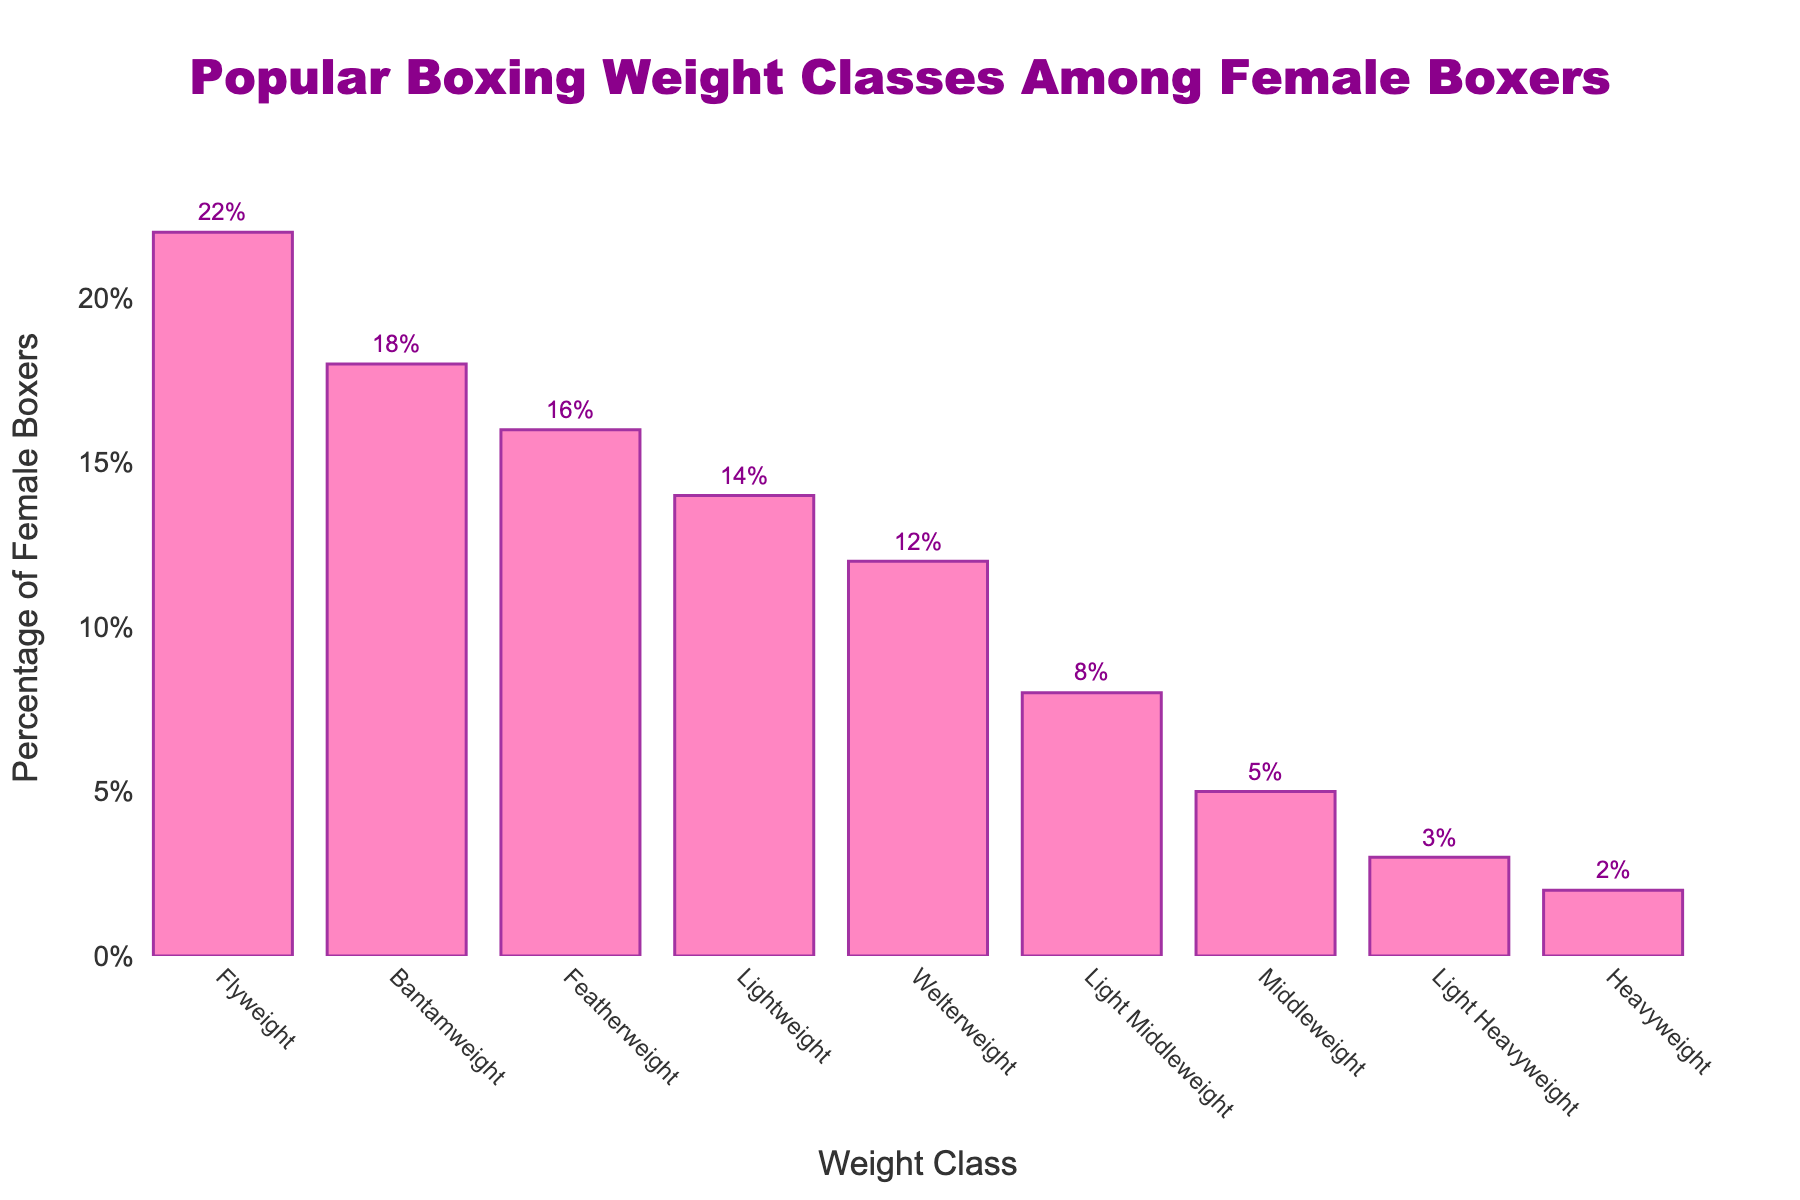What's the most popular weight class among female boxers? Looking at the chart, the weight class with the highest percentage bar is Flyweight with 22%.
Answer: Flyweight Which weight class has a lower percentage of female boxers: Featherweight or Light Heavyweight? Comparing the bars for Featherweight and Light Heavyweight, Featherweight has 16% while Light Heavyweight has 3%. Therefore, Light Heavyweight has a lower percentage.
Answer: Light Heavyweight What is the difference in percentage between Flyweight and Heavyweight boxers? The bar for Flyweight shows 22% and for Heavyweight it shows 2%. The difference is 22% - 2% = 20%.
Answer: 20% How many weight classes have a percentage less than 10%? Observing the chart, Light Middleweight (8%), Middleweight (5%), Light Heavyweight (3%), and Heavyweight (2%) all have percentages less than 10%. This totals to 4 weight classes.
Answer: 4 Is the percentage of boxers in Lightweight greater than in Welterweight? The bar for Lightweight shows 14%, while for Welterweight it shows 12%. Therefore, Lightweight has a greater percentage.
Answer: Yes What is the median percentage of female boxers across all weight classes? List the percentages (2%, 3%, 5%, 8%, 12%, 14%, 16%, 18%, 22%) and find the middle value. The median is 12%.
Answer: 12% Are there more female boxers in the Light Middleweight class or the Middleweight class? Light Middleweight has 8% while Middleweight has 5%. Therefore, Light Middleweight has more.
Answer: Light Middleweight Which weight class has exactly half the percentage of the Flyweight class? The Flyweight class has 22%. Half of that is 11%. Looking at the chart, no weight class has exactly 11%.
Answer: None Does the percentage of Bantamweight boxers sum up with Middleweight boxers reach or surpass 25%? Bantamweight has 18% and Middleweight has 5%. Summing them gives 18% + 5% = 23%, which is less than 25%.
Answer: No 